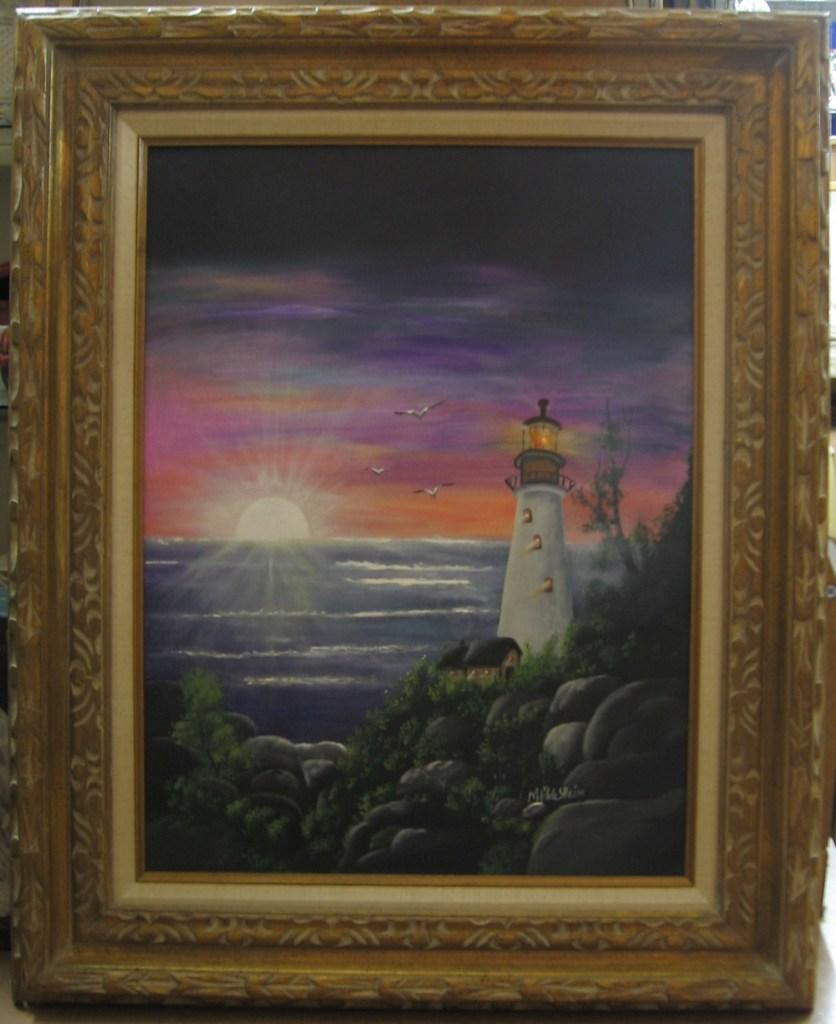What is the main subject of the image? The main subject of the image is a frame. What elements are contained within the frame? The frame contains rocks, plants, a lighthouse, and water. What can be seen in the background of the image? The background of the image includes the sun, clouds, and the sky. What type of industry can be seen in the image? There is no industry present in the image; it features a frame with rocks, plants, a lighthouse, and water, along with a background of the sun, clouds, and sky. How many robins are visible in the image? There are no robins present in the image. 